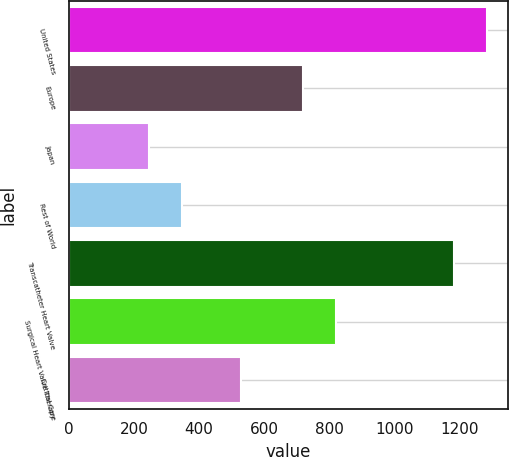<chart> <loc_0><loc_0><loc_500><loc_500><bar_chart><fcel>United States<fcel>Europe<fcel>Japan<fcel>Rest of World<fcel>Transcatheter Heart Valve<fcel>Surgical Heart Valve Therapy<fcel>Critical Care<nl><fcel>1281.97<fcel>717.3<fcel>246.2<fcel>347.87<fcel>1180.3<fcel>818.97<fcel>528.4<nl></chart> 